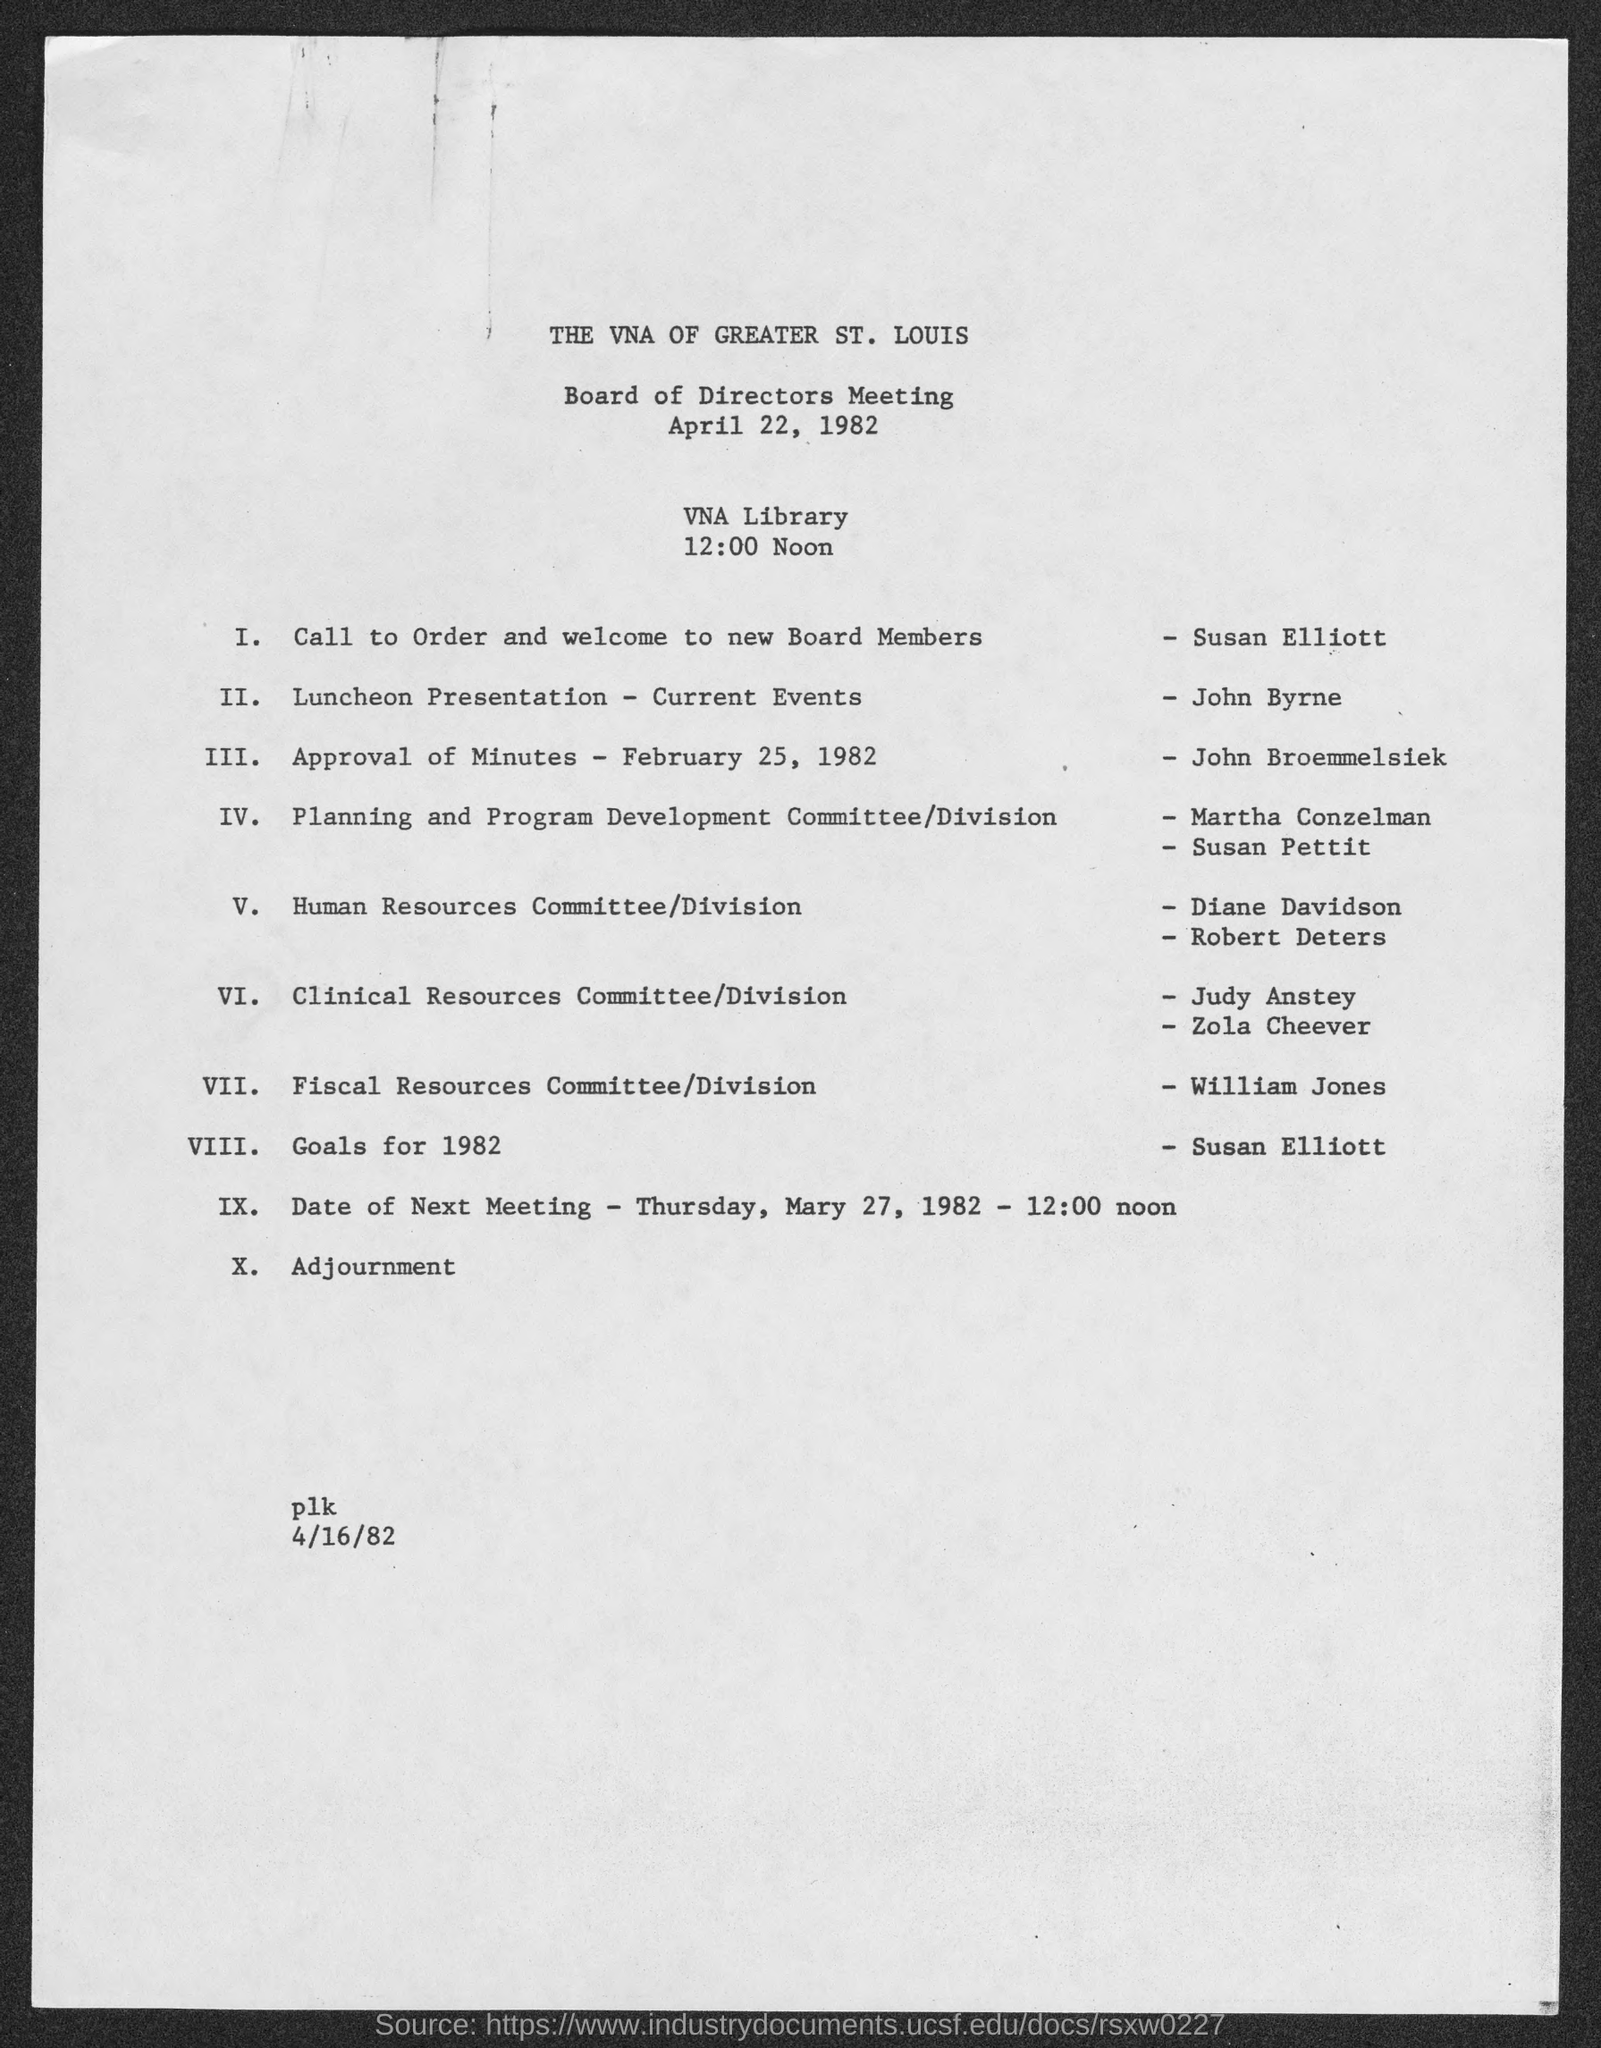Give some essential details in this illustration. The Board of Directors Meeting is organized at the VNA Library. This session was carried out by John Broemmelsiek. 